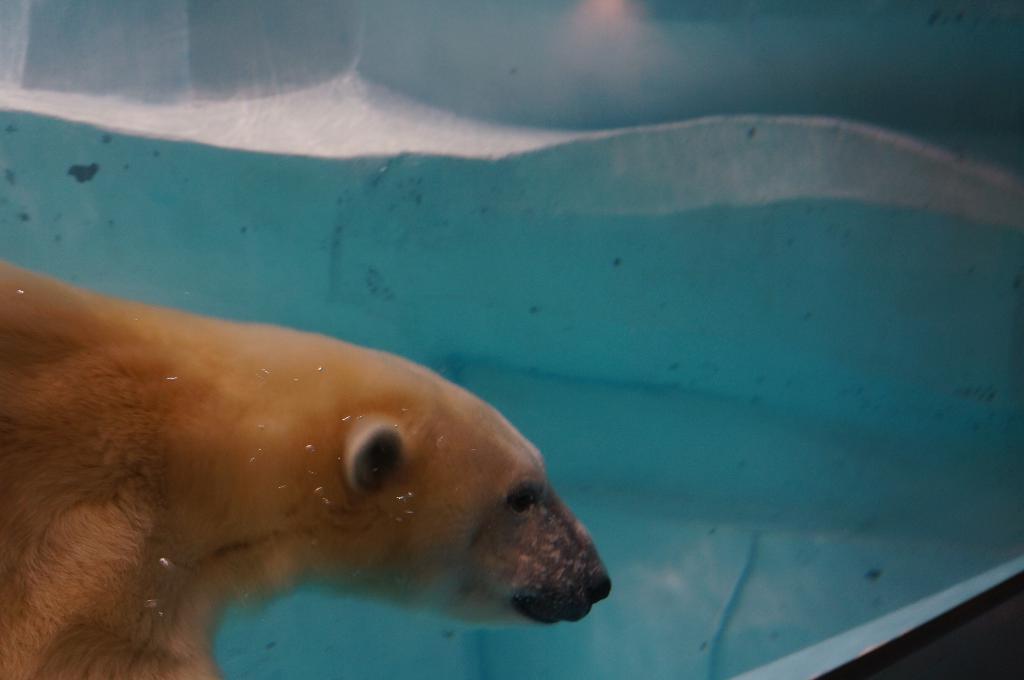In one or two sentences, can you explain what this image depicts? In this picture we can see an animal is present in water. At the bottom right corner we can see the wall. 